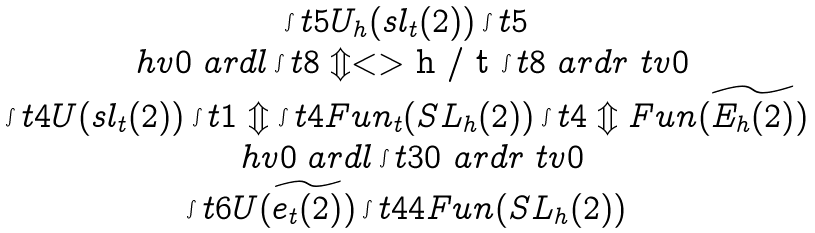Convert formula to latex. <formula><loc_0><loc_0><loc_500><loc_500>\begin{array} { c } \int t { 5 } U _ { h } ( s l _ { t } ( 2 ) ) \int t { 5 } \\ \ h v 0 \ a r d l \int t { 8 } \Updownarrow < > $ h / t $ \int t { 8 } \ a r d r \ t v 0 \\ \int t { 4 } U ( s l _ { t } ( 2 ) ) \int t { 1 } \Updownarrow \int t { 4 } F u n _ { t } ( S L _ { h } ( 2 ) ) \int t { 4 } \Updownarrow F u n ( \widetilde { E _ { h } ( 2 ) } ) \\ \ h v 0 \ a r d l \int t { 3 0 } \ a r d r \ t v 0 \\ \int t { 6 } U ( \widetilde { e _ { t } ( 2 ) } ) \int t { 4 4 } F u n ( S L _ { h } ( 2 ) ) \end{array}</formula> 